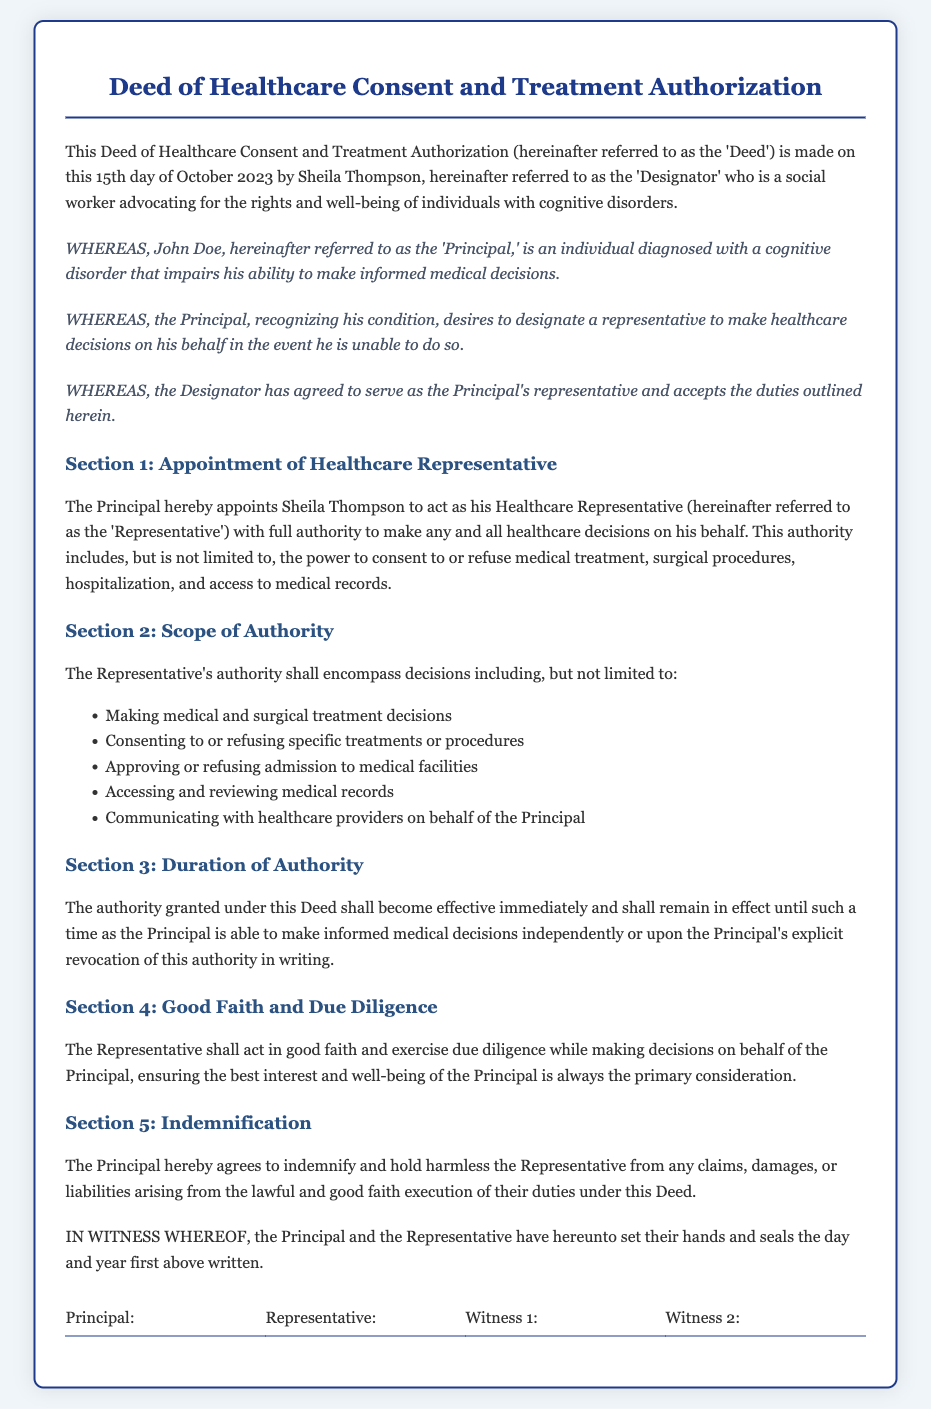what is the name of the Designator? The Designator is the person who creates the Deed, named in the document.
Answer: Sheila Thompson who is referred to as the Principal? The Principal is the individual who is receiving the healthcare consent and treatment authorization.
Answer: John Doe when was the Deed made? The date on which the Deed was created, which is provided in the document.
Answer: 15th day of October 2023 what is the scope of authority granted to the Representative? The scope of authority refers to the powers given to the Representative as detailed in the document.
Answer: Making healthcare decisions how long will the authority granted in this Deed remain effective? This pertains to the duration of the authority granted to the Representative as outlined in the Deed.
Answer: Until the Principal can make informed decisions what must the Representative ensure while making decisions? This outlines the expected conduct and guiding principle for the Representative in their decision-making process.
Answer: Best interest of the Principal what type of indemnity is provided in the Deed? This relates to the protection offered to the Representative from claims arising from their actions under the Deed.
Answer: Indemnify and hold harmless what is required for the Principal to revoke the authority granted? This question pertains to the process the Principal must follow to rescind the authority given in the Deed.
Answer: Explicit revocation in writing 